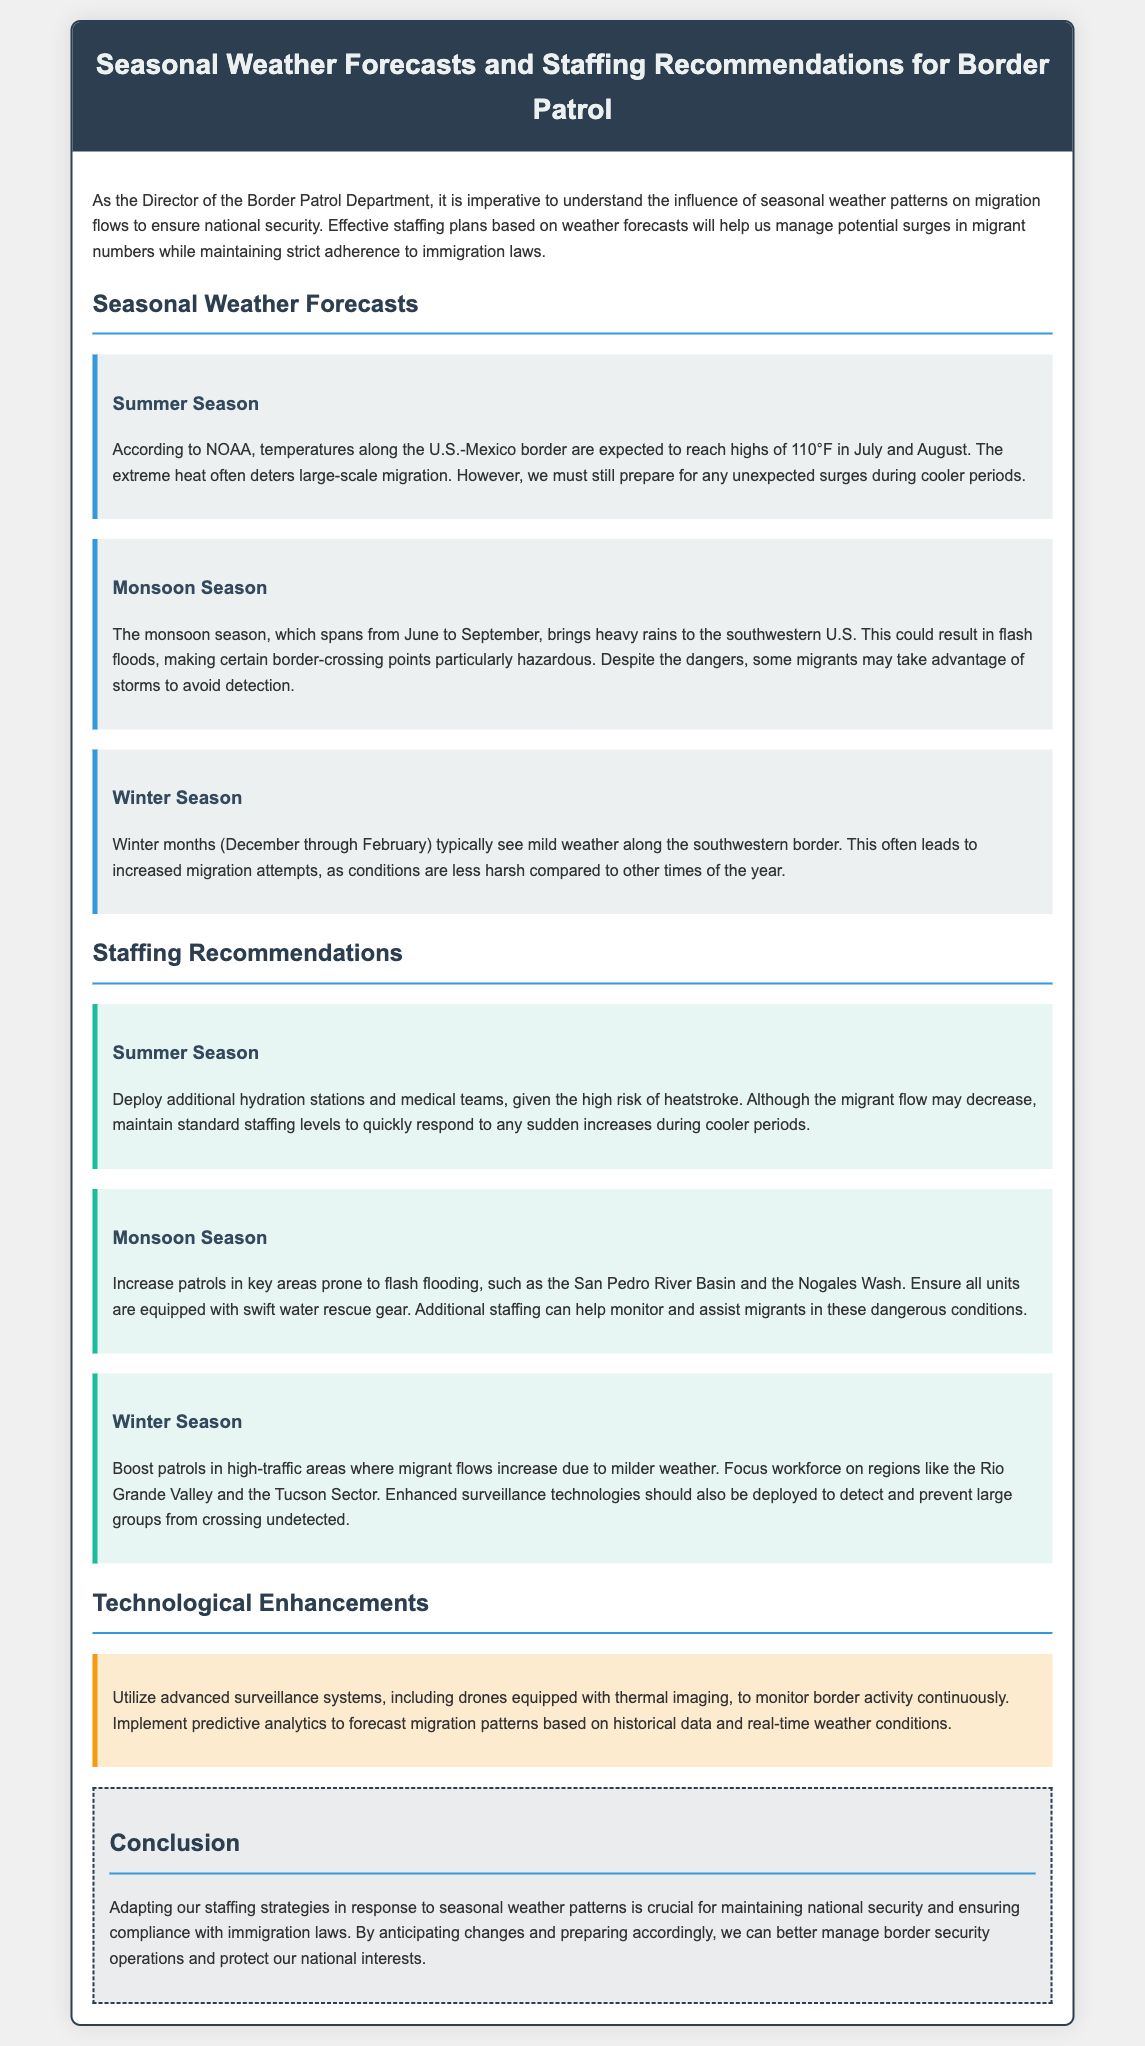What is the expected high temperature in July? The document states that temperatures along the U.S.-Mexico border are expected to reach highs of 110°F in July.
Answer: 110°F During which months does the winter season occur? The winter season is defined in the document as occurring from December through February.
Answer: December through February What staffing recommendation is made for the summer season? The document recommends deploying additional hydration stations and medical teams during the summer season.
Answer: Additional hydration stations and medical teams Which river basin should have increased patrols during monsoon season? The document highlights the San Pedro River Basin as a key area prone to flash flooding requiring increased patrols.
Answer: San Pedro River Basin What technology is suggested for monitoring border activity? The document suggests utilizing advanced surveillance systems, including drones equipped with thermal imaging.
Answer: Drones equipped with thermal imaging Why might there be increased migration attempts in the winter season? The document mentions that milder weather during winter typically leads to increased migration attempts.
Answer: Milder weather What is the purpose of implementing predictive analytics? According to the document, predictive analytics is used to forecast migration patterns based on historical data and real-time weather conditions.
Answer: To forecast migration patterns What background color is used for staffing recommendations? The document indicates that staffing recommendations are highlighted with a background color of #e8f6f3.
Answer: #e8f6f3 